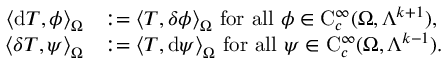Convert formula to latex. <formula><loc_0><loc_0><loc_500><loc_500>\begin{array} { r l } { \left \langle d T , \phi \right \rangle _ { \Omega } } & { \colon = \left \langle T , { \delta } \phi \right \rangle _ { \Omega } f o r a l l \phi \in C _ { c } ^ { \infty } ( \Omega , \Lambda ^ { k + 1 } ) , } \\ { \left \langle { \delta } T , \psi \right \rangle _ { \Omega } } & { \colon = \left \langle T , d \psi \right \rangle _ { \Omega } f o r a l l \psi \in C _ { c } ^ { \infty } ( \Omega , \Lambda ^ { k - 1 } ) . } \end{array}</formula> 